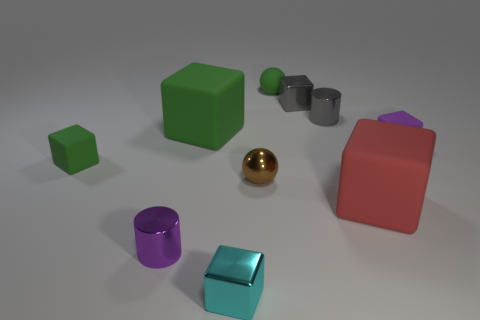Is the color of the matte sphere the same as the big cube to the left of the brown sphere?
Give a very brief answer. Yes. How many tiny matte blocks are the same color as the tiny matte sphere?
Offer a terse response. 1. Are there any red blocks of the same size as the cyan thing?
Make the answer very short. No. How many things are large blue shiny cylinders or gray metallic things?
Your answer should be compact. 2. Does the green thing that is right of the small cyan metallic block have the same size as the red object behind the cyan metal thing?
Give a very brief answer. No. Is there a small cyan thing that has the same shape as the large red rubber thing?
Make the answer very short. Yes. Are there fewer spheres right of the gray cylinder than cyan rubber cylinders?
Ensure brevity in your answer.  No. Does the red matte object have the same shape as the cyan metallic thing?
Your response must be concise. Yes. What size is the purple thing to the right of the purple metal cylinder?
Offer a terse response. Small. What size is the red object that is the same material as the tiny green cube?
Ensure brevity in your answer.  Large. 